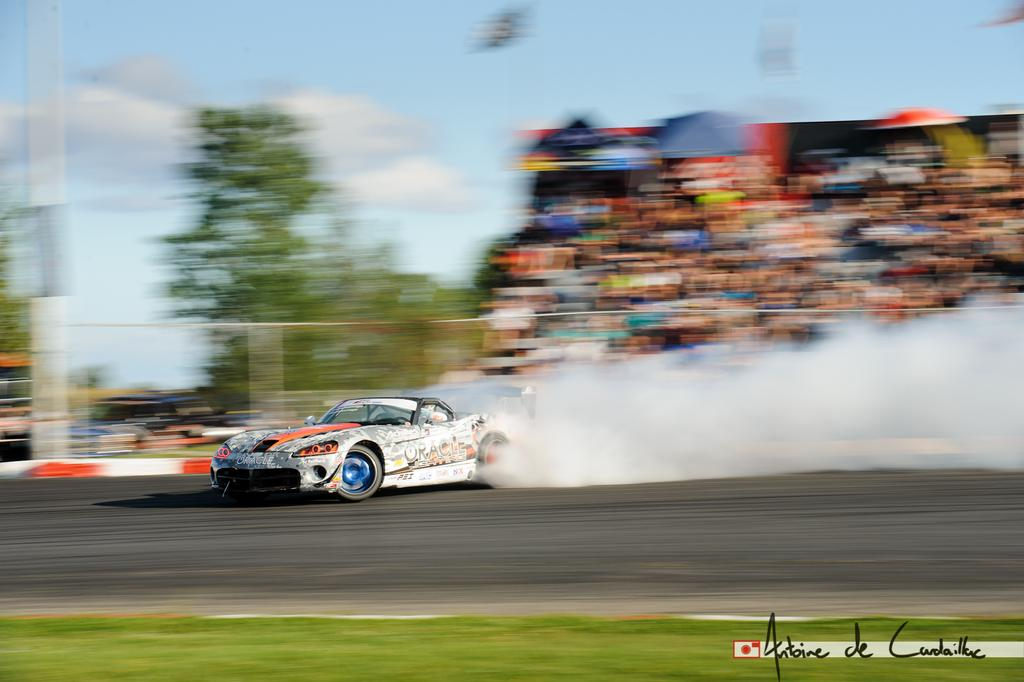What is happening in the image involving a vehicle? There is a car moving on the road in the image. What can be seen in the air in the image? There is smoke visible in the image. Can you describe the people in the image? There are people sitting in the image. What type of natural vegetation is present in the image? There are trees in the image. How would you describe the weather based on the image? The sky is clear in the image, suggesting good weather. Where are the bears sitting in the image? There are no bears present in the image. What type of sponge is being used by the people in the image? There is no sponge visible in the image. 